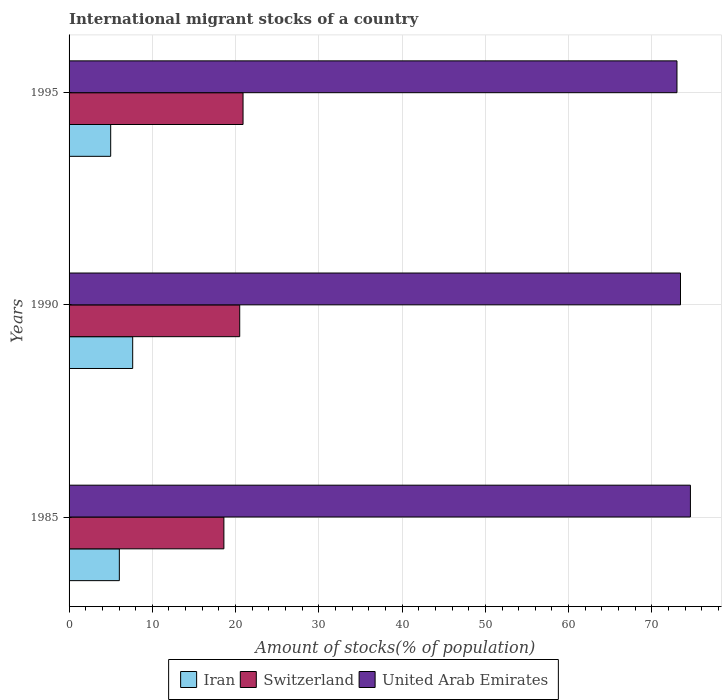How many different coloured bars are there?
Your answer should be compact. 3. Are the number of bars per tick equal to the number of legend labels?
Your answer should be compact. Yes. Are the number of bars on each tick of the Y-axis equal?
Ensure brevity in your answer.  Yes. What is the label of the 3rd group of bars from the top?
Provide a short and direct response. 1985. In how many cases, is the number of bars for a given year not equal to the number of legend labels?
Make the answer very short. 0. What is the amount of stocks in in Switzerland in 1985?
Your response must be concise. 18.6. Across all years, what is the maximum amount of stocks in in Iran?
Offer a terse response. 7.64. Across all years, what is the minimum amount of stocks in in United Arab Emirates?
Offer a terse response. 73.01. In which year was the amount of stocks in in Switzerland minimum?
Your answer should be compact. 1985. What is the total amount of stocks in in Switzerland in the graph?
Your answer should be very brief. 59.99. What is the difference between the amount of stocks in in United Arab Emirates in 1985 and that in 1995?
Your answer should be very brief. 1.62. What is the difference between the amount of stocks in in Switzerland in 1985 and the amount of stocks in in Iran in 1995?
Ensure brevity in your answer.  13.6. What is the average amount of stocks in in Switzerland per year?
Your answer should be compact. 20. In the year 1990, what is the difference between the amount of stocks in in Switzerland and amount of stocks in in Iran?
Provide a short and direct response. 12.86. In how many years, is the amount of stocks in in Switzerland greater than 72 %?
Keep it short and to the point. 0. What is the ratio of the amount of stocks in in Iran in 1990 to that in 1995?
Give a very brief answer. 1.53. Is the difference between the amount of stocks in in Switzerland in 1985 and 1990 greater than the difference between the amount of stocks in in Iran in 1985 and 1990?
Make the answer very short. No. What is the difference between the highest and the second highest amount of stocks in in United Arab Emirates?
Provide a succinct answer. 1.19. What is the difference between the highest and the lowest amount of stocks in in Iran?
Make the answer very short. 2.64. What does the 2nd bar from the top in 1990 represents?
Your answer should be very brief. Switzerland. What does the 3rd bar from the bottom in 1990 represents?
Give a very brief answer. United Arab Emirates. Is it the case that in every year, the sum of the amount of stocks in in Iran and amount of stocks in in Switzerland is greater than the amount of stocks in in United Arab Emirates?
Your response must be concise. No. How many bars are there?
Make the answer very short. 9. Are all the bars in the graph horizontal?
Your answer should be very brief. Yes. How many years are there in the graph?
Your answer should be compact. 3. What is the difference between two consecutive major ticks on the X-axis?
Offer a terse response. 10. Does the graph contain any zero values?
Offer a very short reply. No. Does the graph contain grids?
Keep it short and to the point. Yes. What is the title of the graph?
Make the answer very short. International migrant stocks of a country. What is the label or title of the X-axis?
Your answer should be very brief. Amount of stocks(% of population). What is the label or title of the Y-axis?
Provide a succinct answer. Years. What is the Amount of stocks(% of population) in Iran in 1985?
Give a very brief answer. 6.04. What is the Amount of stocks(% of population) of Switzerland in 1985?
Make the answer very short. 18.6. What is the Amount of stocks(% of population) of United Arab Emirates in 1985?
Give a very brief answer. 74.63. What is the Amount of stocks(% of population) of Iran in 1990?
Offer a terse response. 7.64. What is the Amount of stocks(% of population) in Switzerland in 1990?
Keep it short and to the point. 20.5. What is the Amount of stocks(% of population) of United Arab Emirates in 1990?
Offer a very short reply. 73.44. What is the Amount of stocks(% of population) of Iran in 1995?
Your answer should be compact. 5. What is the Amount of stocks(% of population) in Switzerland in 1995?
Give a very brief answer. 20.9. What is the Amount of stocks(% of population) of United Arab Emirates in 1995?
Offer a very short reply. 73.01. Across all years, what is the maximum Amount of stocks(% of population) in Iran?
Offer a very short reply. 7.64. Across all years, what is the maximum Amount of stocks(% of population) in Switzerland?
Ensure brevity in your answer.  20.9. Across all years, what is the maximum Amount of stocks(% of population) of United Arab Emirates?
Ensure brevity in your answer.  74.63. Across all years, what is the minimum Amount of stocks(% of population) in Iran?
Give a very brief answer. 5. Across all years, what is the minimum Amount of stocks(% of population) in Switzerland?
Make the answer very short. 18.6. Across all years, what is the minimum Amount of stocks(% of population) in United Arab Emirates?
Your response must be concise. 73.01. What is the total Amount of stocks(% of population) in Iran in the graph?
Your answer should be very brief. 18.68. What is the total Amount of stocks(% of population) in Switzerland in the graph?
Your answer should be very brief. 59.99. What is the total Amount of stocks(% of population) in United Arab Emirates in the graph?
Provide a succinct answer. 221.08. What is the difference between the Amount of stocks(% of population) in Iran in 1985 and that in 1990?
Provide a short and direct response. -1.6. What is the difference between the Amount of stocks(% of population) in Switzerland in 1985 and that in 1990?
Your response must be concise. -1.9. What is the difference between the Amount of stocks(% of population) in United Arab Emirates in 1985 and that in 1990?
Offer a very short reply. 1.19. What is the difference between the Amount of stocks(% of population) of Iran in 1985 and that in 1995?
Your answer should be compact. 1.04. What is the difference between the Amount of stocks(% of population) in Switzerland in 1985 and that in 1995?
Make the answer very short. -2.3. What is the difference between the Amount of stocks(% of population) of United Arab Emirates in 1985 and that in 1995?
Offer a very short reply. 1.62. What is the difference between the Amount of stocks(% of population) of Iran in 1990 and that in 1995?
Provide a short and direct response. 2.64. What is the difference between the Amount of stocks(% of population) of Switzerland in 1990 and that in 1995?
Your answer should be compact. -0.4. What is the difference between the Amount of stocks(% of population) of United Arab Emirates in 1990 and that in 1995?
Keep it short and to the point. 0.42. What is the difference between the Amount of stocks(% of population) of Iran in 1985 and the Amount of stocks(% of population) of Switzerland in 1990?
Your answer should be very brief. -14.46. What is the difference between the Amount of stocks(% of population) in Iran in 1985 and the Amount of stocks(% of population) in United Arab Emirates in 1990?
Ensure brevity in your answer.  -67.4. What is the difference between the Amount of stocks(% of population) of Switzerland in 1985 and the Amount of stocks(% of population) of United Arab Emirates in 1990?
Keep it short and to the point. -54.84. What is the difference between the Amount of stocks(% of population) of Iran in 1985 and the Amount of stocks(% of population) of Switzerland in 1995?
Your answer should be compact. -14.86. What is the difference between the Amount of stocks(% of population) of Iran in 1985 and the Amount of stocks(% of population) of United Arab Emirates in 1995?
Keep it short and to the point. -66.98. What is the difference between the Amount of stocks(% of population) of Switzerland in 1985 and the Amount of stocks(% of population) of United Arab Emirates in 1995?
Give a very brief answer. -54.42. What is the difference between the Amount of stocks(% of population) in Iran in 1990 and the Amount of stocks(% of population) in Switzerland in 1995?
Ensure brevity in your answer.  -13.26. What is the difference between the Amount of stocks(% of population) in Iran in 1990 and the Amount of stocks(% of population) in United Arab Emirates in 1995?
Keep it short and to the point. -65.37. What is the difference between the Amount of stocks(% of population) in Switzerland in 1990 and the Amount of stocks(% of population) in United Arab Emirates in 1995?
Your answer should be very brief. -52.52. What is the average Amount of stocks(% of population) in Iran per year?
Provide a short and direct response. 6.23. What is the average Amount of stocks(% of population) in Switzerland per year?
Provide a short and direct response. 20. What is the average Amount of stocks(% of population) of United Arab Emirates per year?
Provide a short and direct response. 73.69. In the year 1985, what is the difference between the Amount of stocks(% of population) of Iran and Amount of stocks(% of population) of Switzerland?
Offer a terse response. -12.56. In the year 1985, what is the difference between the Amount of stocks(% of population) in Iran and Amount of stocks(% of population) in United Arab Emirates?
Provide a succinct answer. -68.59. In the year 1985, what is the difference between the Amount of stocks(% of population) of Switzerland and Amount of stocks(% of population) of United Arab Emirates?
Offer a very short reply. -56.04. In the year 1990, what is the difference between the Amount of stocks(% of population) of Iran and Amount of stocks(% of population) of Switzerland?
Provide a short and direct response. -12.86. In the year 1990, what is the difference between the Amount of stocks(% of population) of Iran and Amount of stocks(% of population) of United Arab Emirates?
Ensure brevity in your answer.  -65.8. In the year 1990, what is the difference between the Amount of stocks(% of population) in Switzerland and Amount of stocks(% of population) in United Arab Emirates?
Your answer should be compact. -52.94. In the year 1995, what is the difference between the Amount of stocks(% of population) in Iran and Amount of stocks(% of population) in Switzerland?
Provide a succinct answer. -15.9. In the year 1995, what is the difference between the Amount of stocks(% of population) of Iran and Amount of stocks(% of population) of United Arab Emirates?
Your answer should be compact. -68.02. In the year 1995, what is the difference between the Amount of stocks(% of population) of Switzerland and Amount of stocks(% of population) of United Arab Emirates?
Offer a terse response. -52.12. What is the ratio of the Amount of stocks(% of population) in Iran in 1985 to that in 1990?
Make the answer very short. 0.79. What is the ratio of the Amount of stocks(% of population) in Switzerland in 1985 to that in 1990?
Offer a terse response. 0.91. What is the ratio of the Amount of stocks(% of population) in United Arab Emirates in 1985 to that in 1990?
Your response must be concise. 1.02. What is the ratio of the Amount of stocks(% of population) of Iran in 1985 to that in 1995?
Give a very brief answer. 1.21. What is the ratio of the Amount of stocks(% of population) in Switzerland in 1985 to that in 1995?
Your response must be concise. 0.89. What is the ratio of the Amount of stocks(% of population) of United Arab Emirates in 1985 to that in 1995?
Offer a terse response. 1.02. What is the ratio of the Amount of stocks(% of population) in Iran in 1990 to that in 1995?
Your answer should be compact. 1.53. What is the ratio of the Amount of stocks(% of population) in Switzerland in 1990 to that in 1995?
Your response must be concise. 0.98. What is the difference between the highest and the second highest Amount of stocks(% of population) of Iran?
Your answer should be very brief. 1.6. What is the difference between the highest and the second highest Amount of stocks(% of population) of Switzerland?
Your response must be concise. 0.4. What is the difference between the highest and the second highest Amount of stocks(% of population) of United Arab Emirates?
Offer a terse response. 1.19. What is the difference between the highest and the lowest Amount of stocks(% of population) of Iran?
Your response must be concise. 2.64. What is the difference between the highest and the lowest Amount of stocks(% of population) in Switzerland?
Provide a short and direct response. 2.3. What is the difference between the highest and the lowest Amount of stocks(% of population) in United Arab Emirates?
Provide a short and direct response. 1.62. 